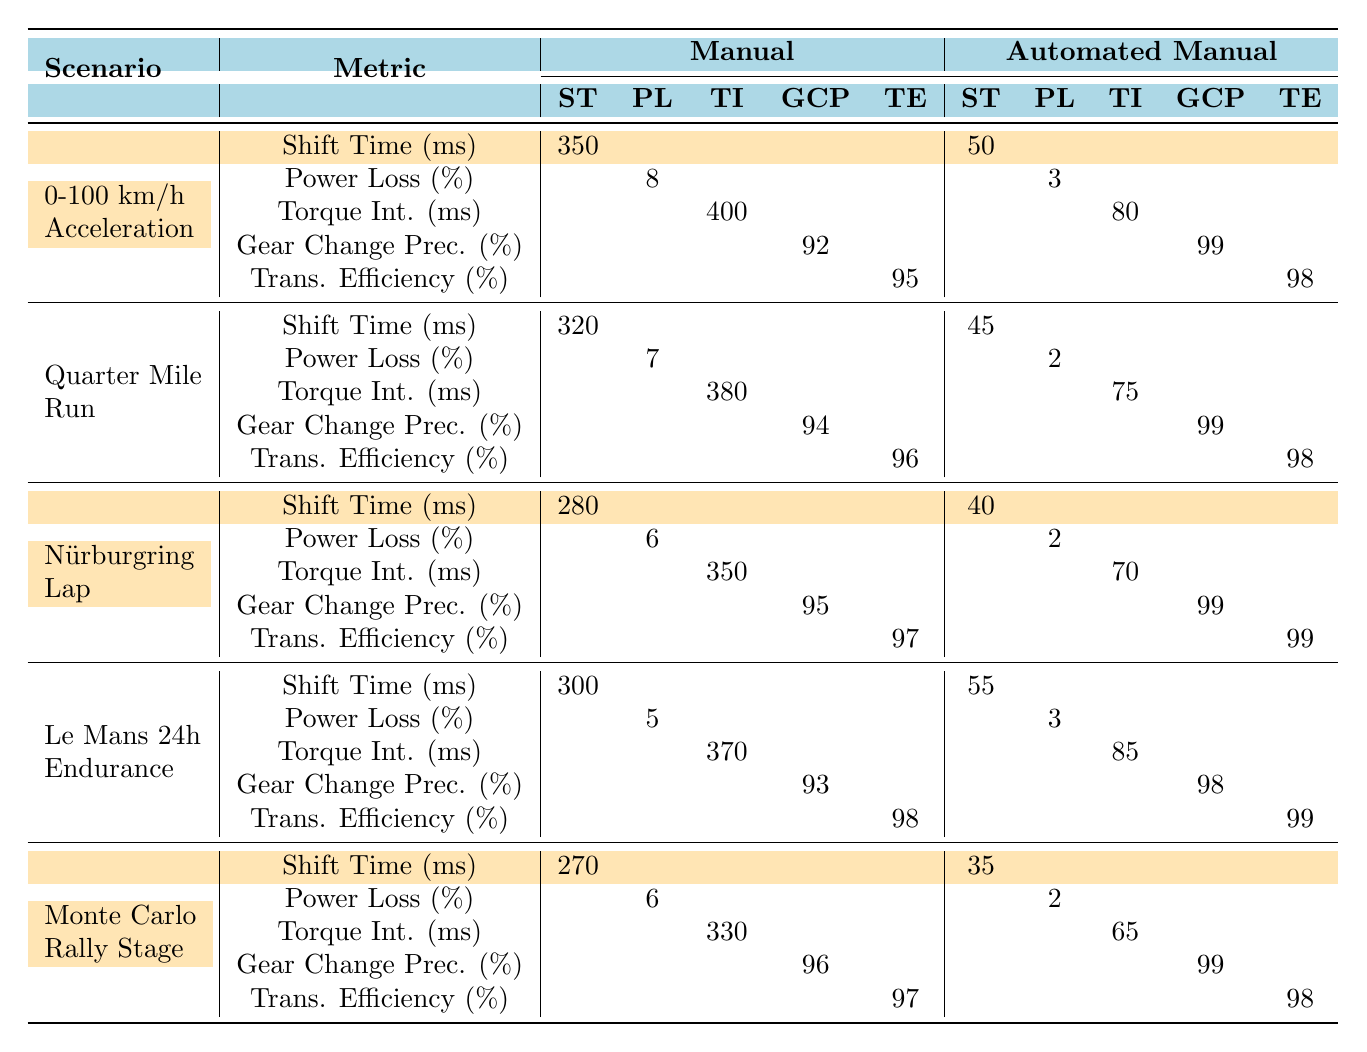What is the shift time for the Automated Manual transmission in the Quarter Mile Run scenario? From the table, the value for Shift Time (ms) under the Automated Manual column for the Quarter Mile Run scenario is listed as 45.
Answer: 45 ms What is the Power Loss during the 0-100 km/h Acceleration for the Manual transmission? The table states that the Power Loss (%) for the Manual transmission in the 0-100 km/h Acceleration scenario is 8%.
Answer: 8% Which transmission shows higher Gear Change Precision in the Nürburgring Lap? Comparing the Gear Change Precision (%) values in the table, the Manual transmission has 95% and the Automated Manual transmission has 99%. The Automated Manual is higher.
Answer: Automated Manual How much lower is the Power Loss for the Automated Manual transmission compared to the Manual transmission in the Quarter Mile Run? The Power Loss for the Manual transmission is 7% and for the Automated Manual it is 2%. The difference is 7% - 2% = 5%.
Answer: 5% What is the average Transmission Efficiency for both types of transmissions during the Le Mans 24h Endurance? Manual transmission efficiency is 98% and Automated Manual efficiency is 99%. The average is (98% + 99%) / 2 = 98.5%.
Answer: 98.5% In which scenario does the Manual transmission have the longest Torque Interruption? Looking at the Torque Interruption (ms) values for Manual transmission: 400, 380, 350, 370, and 330. The longest value is 400 ms in the 0-100 km/h Acceleration scenario.
Answer: 0-100 km/h Acceleration Does the Automated Manual transmission have a shift time lower than 40 ms in any scenario? Reviewing the shift time values for Automated Manual, the lowest is 35 ms in the Monte Carlo Rally Stage. This confirms that it does.
Answer: Yes What is the total Torque Interruption time for the Manual transmission across all scenarios? The values for the Manual transmission Torque Interruption are 400, 380, 350, 370, and 330 ms. Summing these gives 400 + 380 + 350 + 370 + 330 = 1830 ms.
Answer: 1830 ms Which scenario has the best Transmission Efficiency for both types of transmissions? The efficiencies listed are 95% (Manual) and 98% (Automated Manual) in the 0-100 km/h Acceleration scenario. Automated Manual has the best efficiency of 98%.
Answer: 98% What is the difference in total shift times between Manual and Automated Manual transmissions across all scenarios? Shift times for Manual are 350, 320, 280, 300, 270 ms summing to 1520 ms; Automated Manual times are 50, 45, 40, 55, 35 ms summing to 225 ms. The difference is 1520 ms - 225 ms = 1295 ms.
Answer: 1295 ms 